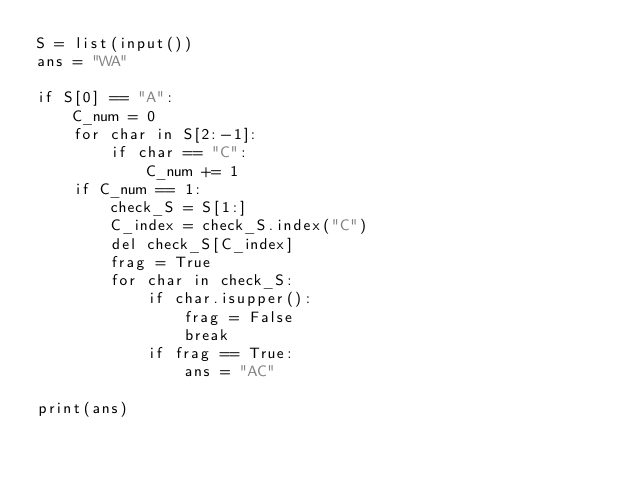<code> <loc_0><loc_0><loc_500><loc_500><_Python_>S = list(input())
ans = "WA"

if S[0] == "A":
    C_num = 0
    for char in S[2:-1]:
        if char == "C":
            C_num += 1
    if C_num == 1:
        check_S = S[1:]
        C_index = check_S.index("C")
        del check_S[C_index]
        frag = True
        for char in check_S:
            if char.isupper():
                frag = False
                break
            if frag == True:
                ans = "AC"

print(ans)
</code> 